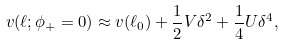<formula> <loc_0><loc_0><loc_500><loc_500>v ( \ell ; \phi _ { + } = 0 ) \approx v ( \ell _ { 0 } ) + \frac { 1 } { 2 } V \delta ^ { 2 } + \frac { 1 } { 4 } U \delta ^ { 4 } ,</formula> 